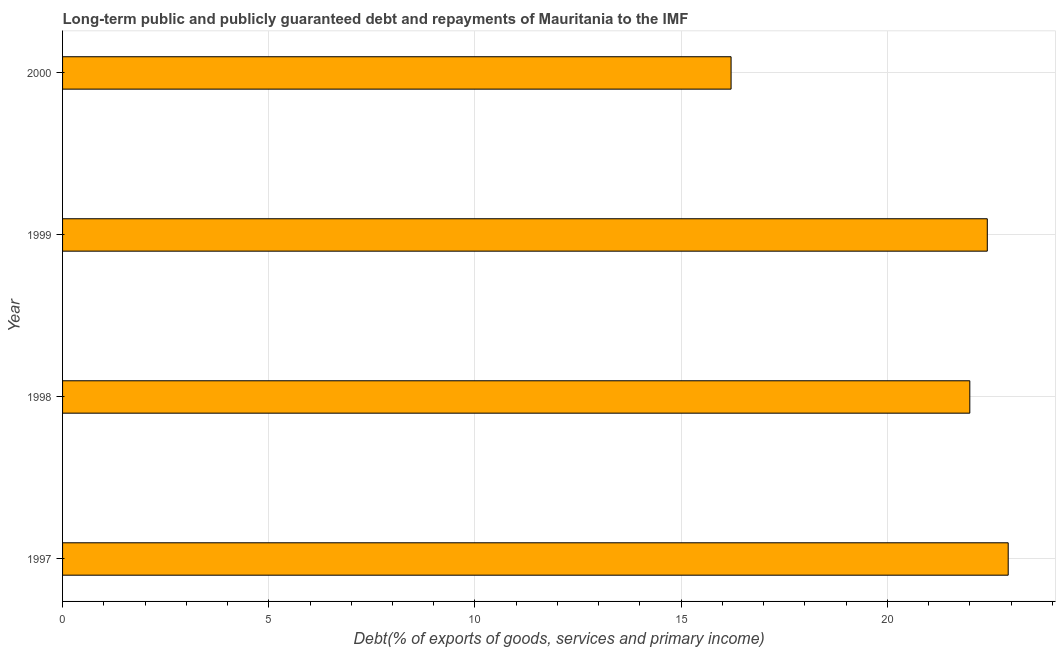Does the graph contain any zero values?
Offer a terse response. No. Does the graph contain grids?
Your answer should be very brief. Yes. What is the title of the graph?
Ensure brevity in your answer.  Long-term public and publicly guaranteed debt and repayments of Mauritania to the IMF. What is the label or title of the X-axis?
Keep it short and to the point. Debt(% of exports of goods, services and primary income). What is the label or title of the Y-axis?
Give a very brief answer. Year. What is the debt service in 2000?
Make the answer very short. 16.21. Across all years, what is the maximum debt service?
Offer a very short reply. 22.93. Across all years, what is the minimum debt service?
Your answer should be very brief. 16.21. In which year was the debt service maximum?
Your response must be concise. 1997. In which year was the debt service minimum?
Provide a short and direct response. 2000. What is the sum of the debt service?
Your response must be concise. 83.57. What is the difference between the debt service in 1998 and 1999?
Offer a very short reply. -0.42. What is the average debt service per year?
Your answer should be very brief. 20.89. What is the median debt service?
Offer a very short reply. 22.21. In how many years, is the debt service greater than 21 %?
Keep it short and to the point. 3. Do a majority of the years between 1999 and 1998 (inclusive) have debt service greater than 13 %?
Keep it short and to the point. No. What is the ratio of the debt service in 1999 to that in 2000?
Your response must be concise. 1.38. Is the debt service in 1997 less than that in 1999?
Your response must be concise. No. Is the difference between the debt service in 1997 and 1998 greater than the difference between any two years?
Offer a terse response. No. What is the difference between the highest and the second highest debt service?
Ensure brevity in your answer.  0.51. What is the difference between the highest and the lowest debt service?
Offer a terse response. 6.72. In how many years, is the debt service greater than the average debt service taken over all years?
Keep it short and to the point. 3. How many bars are there?
Offer a terse response. 4. How many years are there in the graph?
Your response must be concise. 4. What is the difference between two consecutive major ticks on the X-axis?
Make the answer very short. 5. What is the Debt(% of exports of goods, services and primary income) of 1997?
Ensure brevity in your answer.  22.93. What is the Debt(% of exports of goods, services and primary income) of 1999?
Ensure brevity in your answer.  22.42. What is the Debt(% of exports of goods, services and primary income) of 2000?
Your response must be concise. 16.21. What is the difference between the Debt(% of exports of goods, services and primary income) in 1997 and 1998?
Provide a short and direct response. 0.93. What is the difference between the Debt(% of exports of goods, services and primary income) in 1997 and 1999?
Give a very brief answer. 0.51. What is the difference between the Debt(% of exports of goods, services and primary income) in 1997 and 2000?
Provide a short and direct response. 6.72. What is the difference between the Debt(% of exports of goods, services and primary income) in 1998 and 1999?
Ensure brevity in your answer.  -0.42. What is the difference between the Debt(% of exports of goods, services and primary income) in 1998 and 2000?
Make the answer very short. 5.79. What is the difference between the Debt(% of exports of goods, services and primary income) in 1999 and 2000?
Your response must be concise. 6.21. What is the ratio of the Debt(% of exports of goods, services and primary income) in 1997 to that in 1998?
Ensure brevity in your answer.  1.04. What is the ratio of the Debt(% of exports of goods, services and primary income) in 1997 to that in 2000?
Give a very brief answer. 1.42. What is the ratio of the Debt(% of exports of goods, services and primary income) in 1998 to that in 2000?
Make the answer very short. 1.36. What is the ratio of the Debt(% of exports of goods, services and primary income) in 1999 to that in 2000?
Offer a very short reply. 1.38. 